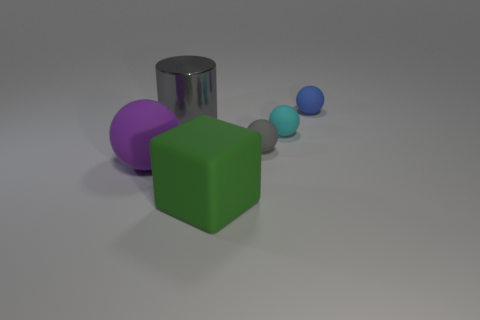Subtract all cyan balls. How many balls are left? 3 Add 1 green objects. How many objects exist? 7 Subtract 1 green cubes. How many objects are left? 5 Subtract all balls. How many objects are left? 2 Subtract 2 balls. How many balls are left? 2 Subtract all blue spheres. Subtract all blue cylinders. How many spheres are left? 3 Subtract all brown cubes. How many gray spheres are left? 1 Subtract all big metal things. Subtract all big green rubber things. How many objects are left? 4 Add 4 cyan balls. How many cyan balls are left? 5 Add 5 blue matte balls. How many blue matte balls exist? 6 